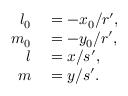<formula> <loc_0><loc_0><loc_500><loc_500>\begin{array} { r l } { l _ { 0 } } & = - x _ { 0 } / r ^ { \prime } , } \\ { m _ { 0 } } & = - y _ { 0 } / r ^ { \prime } , } \\ { l } & = x / s ^ { \prime } , } \\ { m } & = y / s ^ { \prime } . } \end{array}</formula> 